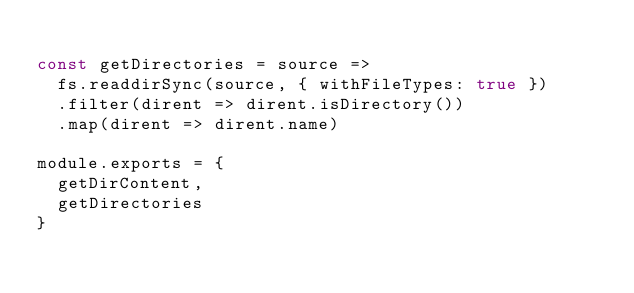<code> <loc_0><loc_0><loc_500><loc_500><_JavaScript_>
const getDirectories = source =>
  fs.readdirSync(source, { withFileTypes: true })
  .filter(dirent => dirent.isDirectory())
  .map(dirent => dirent.name)

module.exports = {
  getDirContent,
  getDirectories
}</code> 